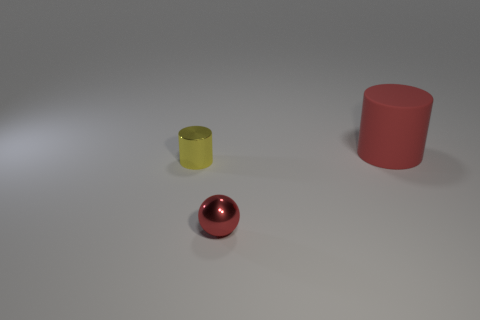How would you describe the lighting in the image? The lighting in the image is diffused and soft, producing gentle shadows and subtly highlighting the objects. The direction of the shadows suggests a light source located above and slightly to the right of the scene. 